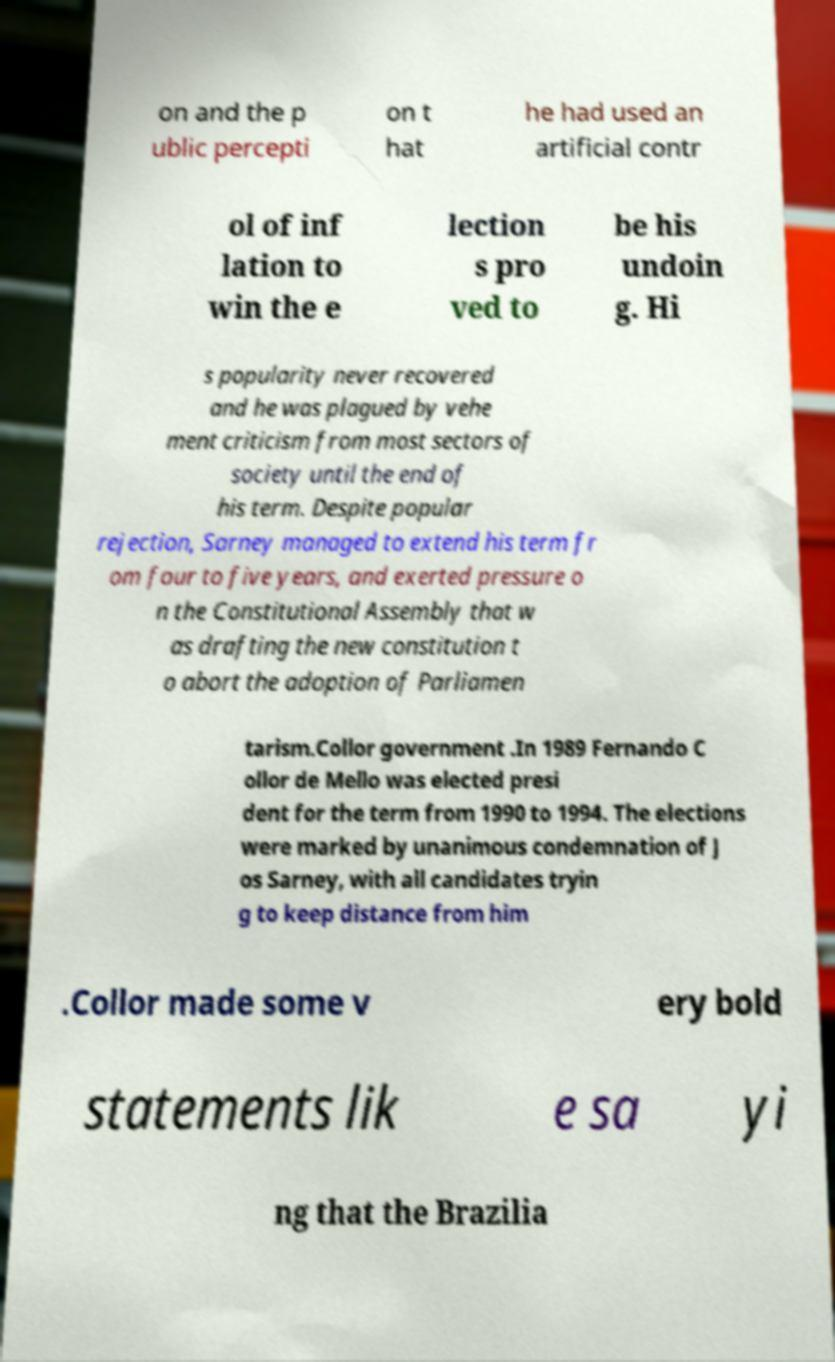Can you provide a summary of the political issues discussed in the text? The text discusses significant political turmoil in Brazil involving leaders Jos� Sarney and Fernando Collor de Mello. It mentions Sarney's unpopularity due to perceived economic mismanagement, his term extension, and exerting influence over constitutional matters. It also brings up Collor's campaign and presidency, characterized by his distancing from Sarney and making bold public statements. 